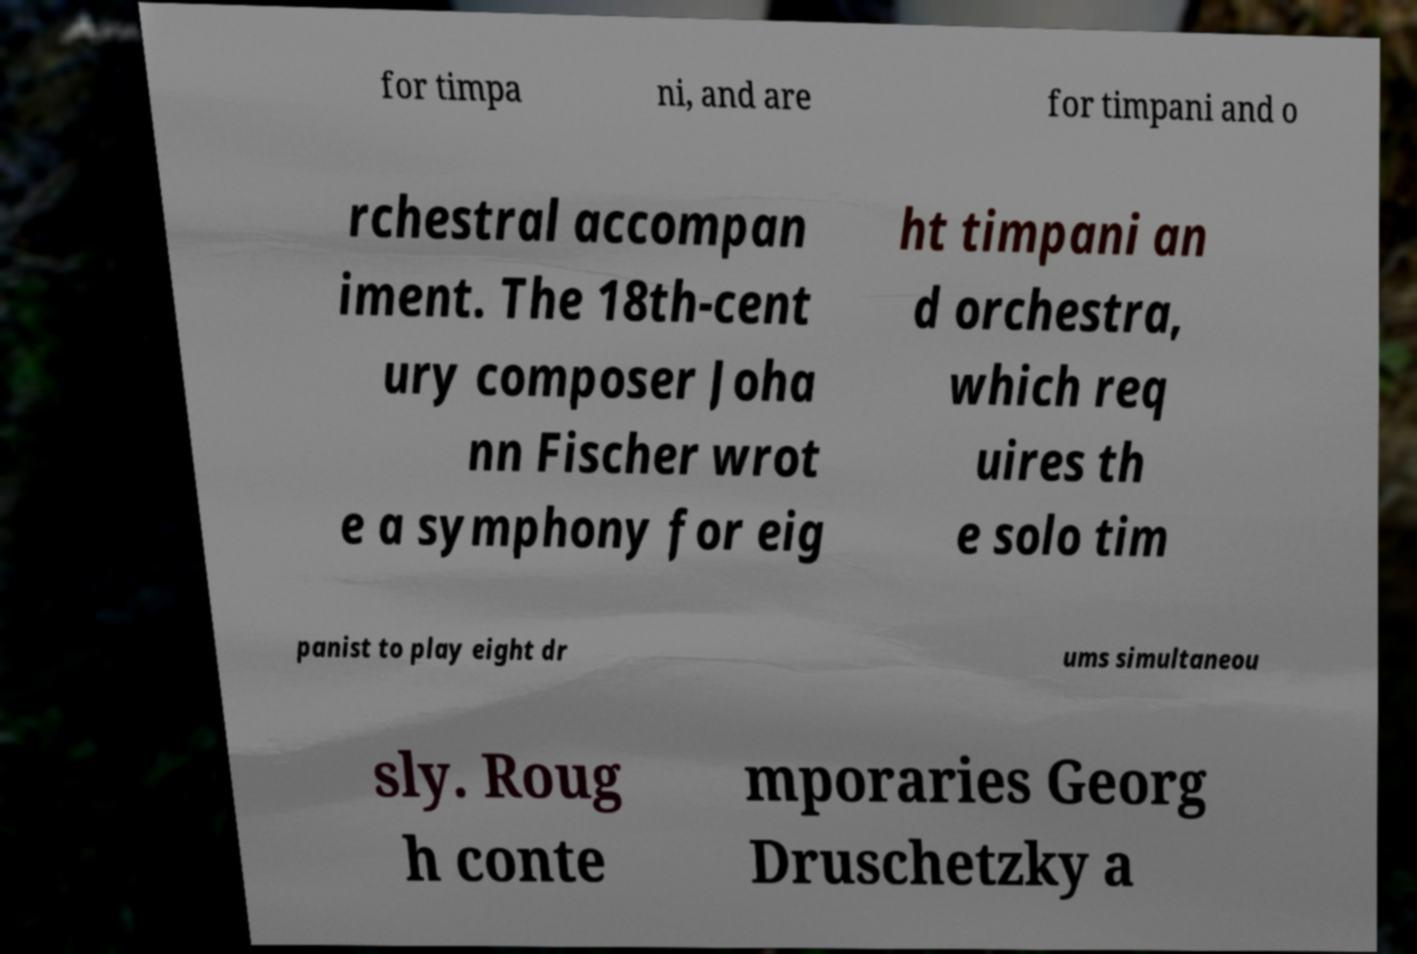Could you assist in decoding the text presented in this image and type it out clearly? for timpa ni, and are for timpani and o rchestral accompan iment. The 18th-cent ury composer Joha nn Fischer wrot e a symphony for eig ht timpani an d orchestra, which req uires th e solo tim panist to play eight dr ums simultaneou sly. Roug h conte mporaries Georg Druschetzky a 